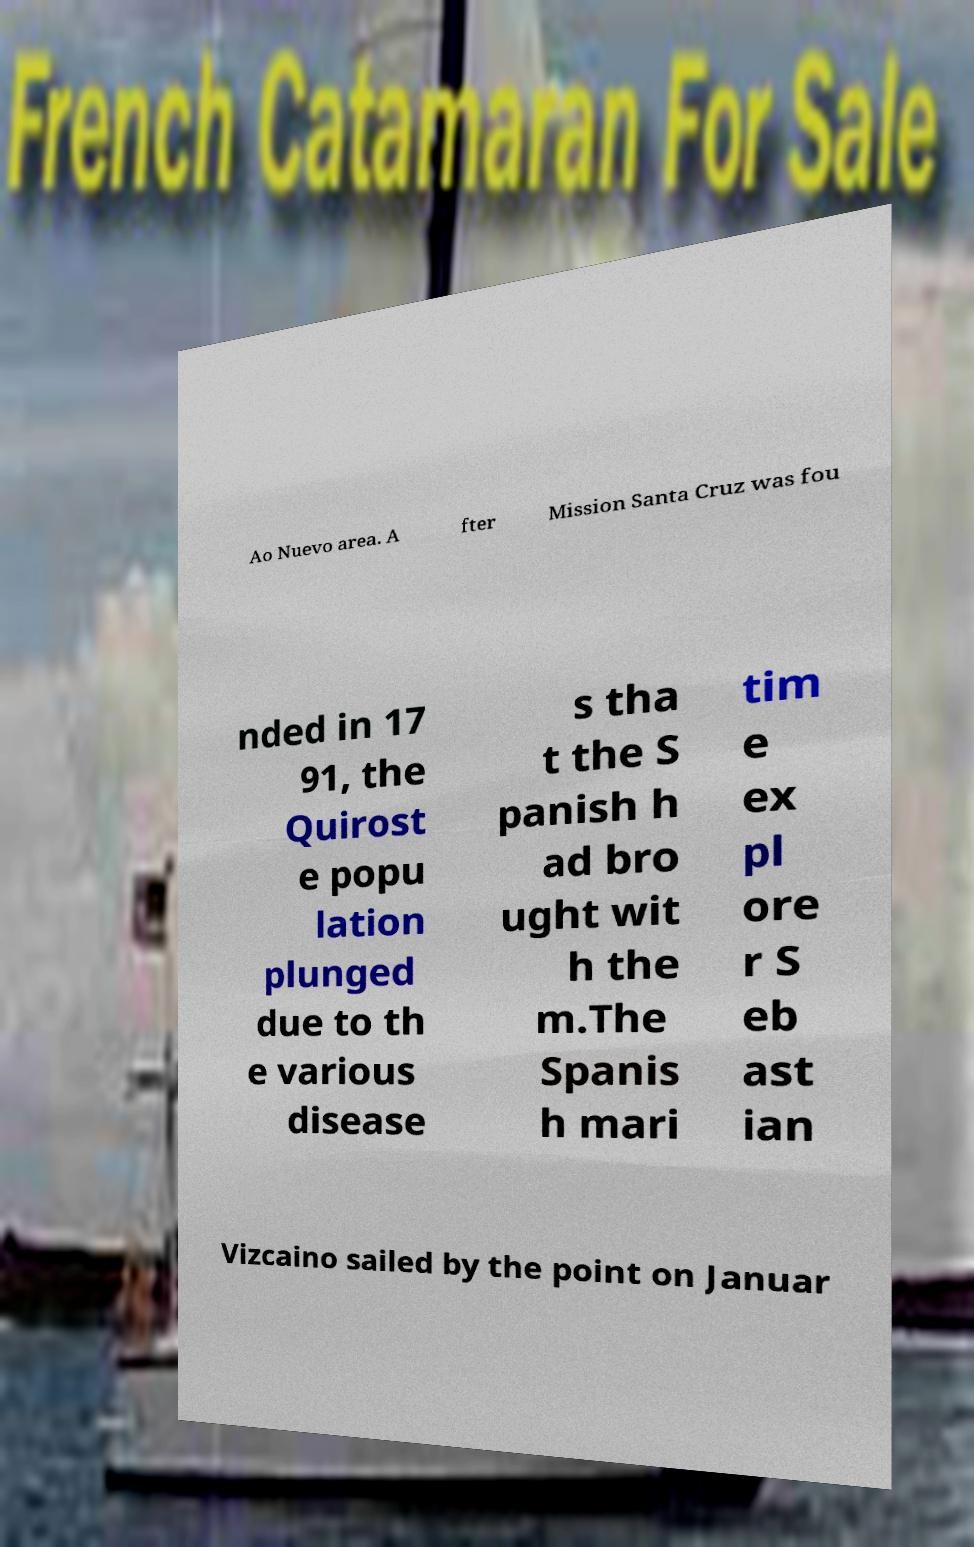I need the written content from this picture converted into text. Can you do that? Ao Nuevo area. A fter Mission Santa Cruz was fou nded in 17 91, the Quirost e popu lation plunged due to th e various disease s tha t the S panish h ad bro ught wit h the m.The Spanis h mari tim e ex pl ore r S eb ast ian Vizcaino sailed by the point on Januar 